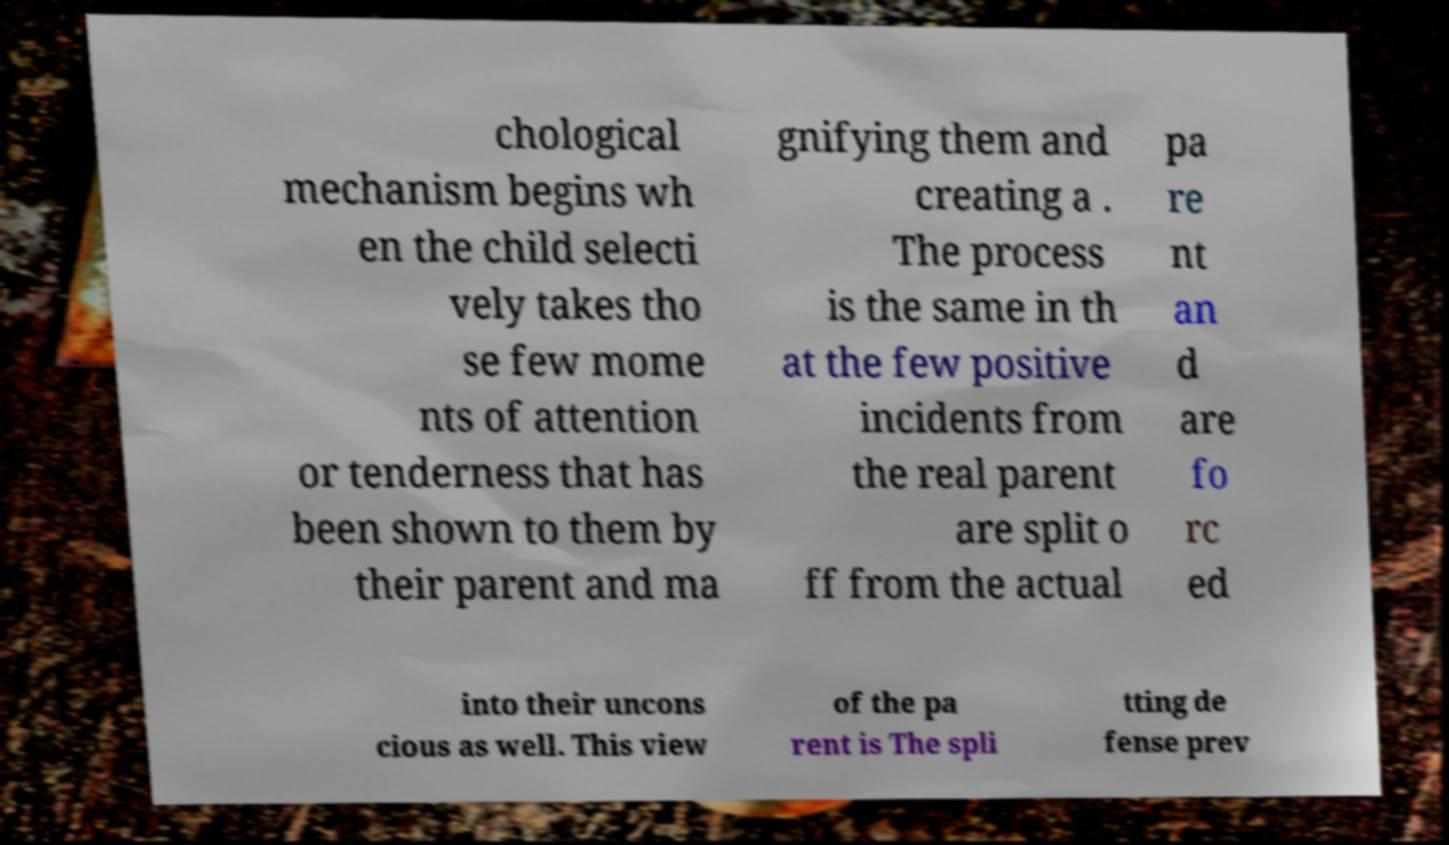There's text embedded in this image that I need extracted. Can you transcribe it verbatim? chological mechanism begins wh en the child selecti vely takes tho se few mome nts of attention or tenderness that has been shown to them by their parent and ma gnifying them and creating a . The process is the same in th at the few positive incidents from the real parent are split o ff from the actual pa re nt an d are fo rc ed into their uncons cious as well. This view of the pa rent is The spli tting de fense prev 